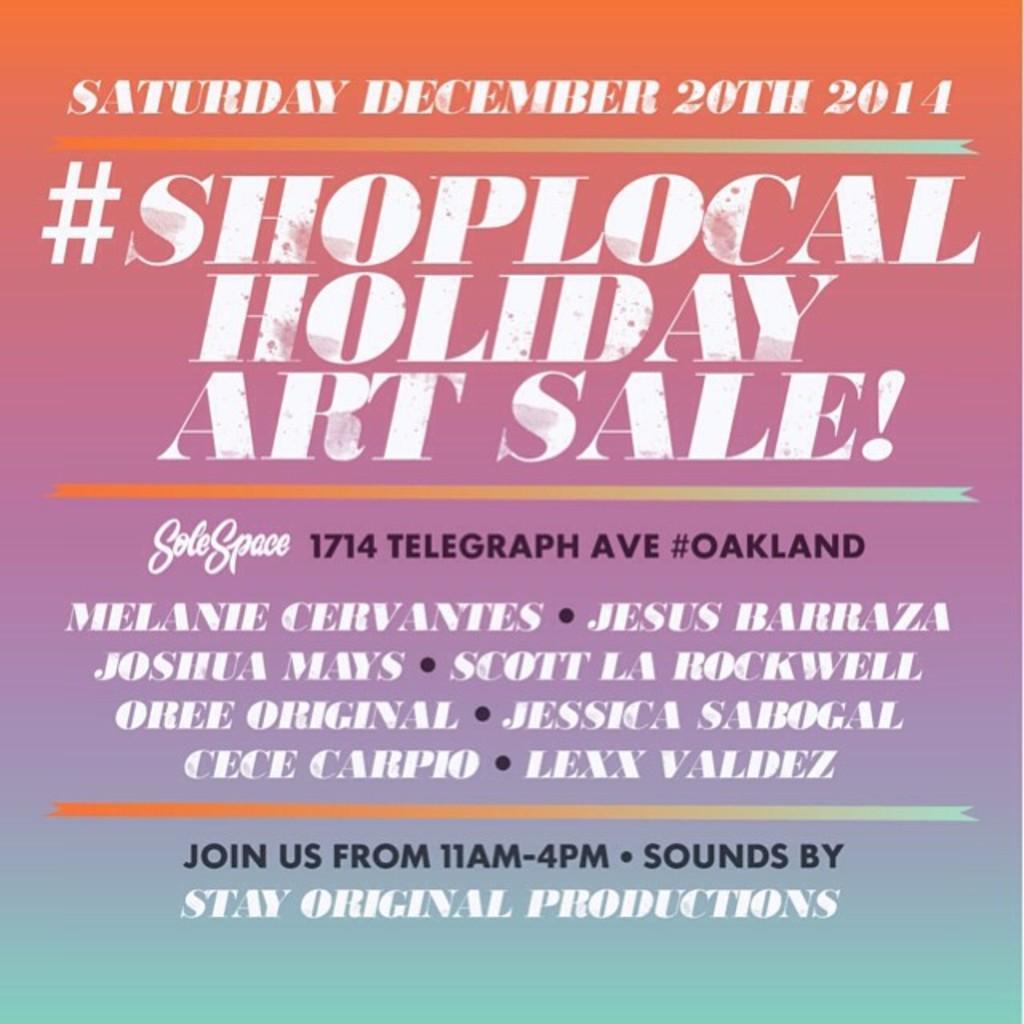Could you give a brief overview of what you see in this image? In this image, there is an advertisement contains some text. 